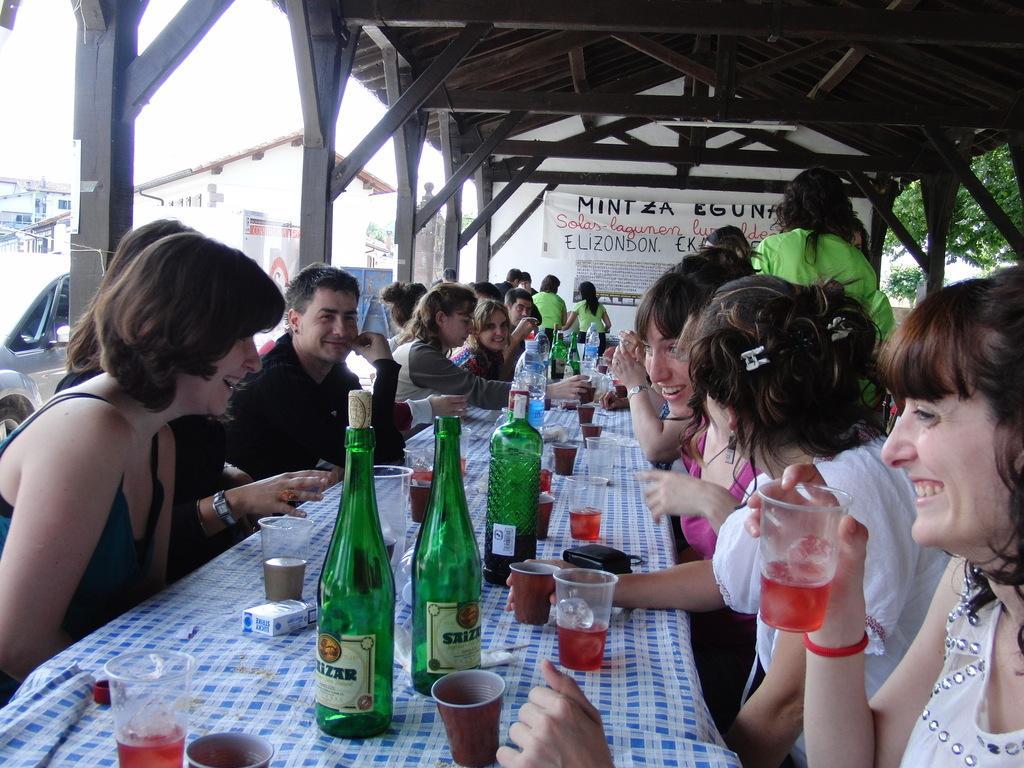How would you summarize this image in a sentence or two? This Picture describe about the a group of man and woman sitting around the long table drinking and enjoying. In front we can see the a woman wearing white dress holding the red wine glass in her hand and smiling. Beside one is discussing something with the other girl, Opposite a woman is also smiling and enjoying the drink. On the table we can see three green wine bottles, tea cups, water bottles, wine glasses and cigarette packet on the top of the table. On the top we can see the wooden rafters and clear sky. 